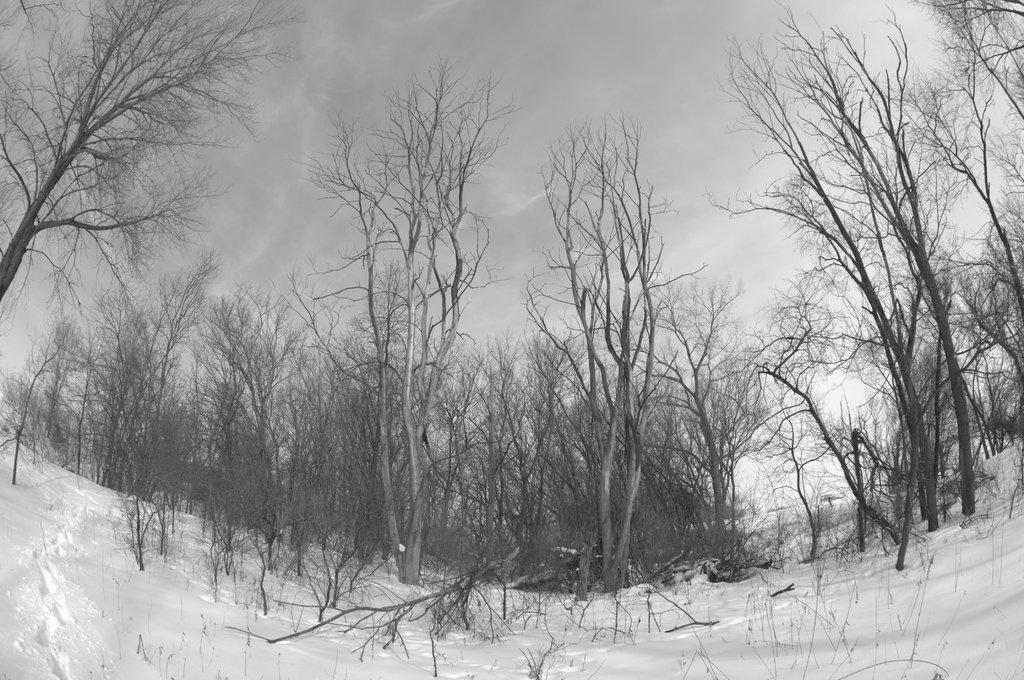What is on the snow in the image? There are cut down trees on the snow. What can be seen in the background of the image? There are bare trees in the background. What is visible in the sky in the image? Clouds are visible in the sky. What type of wall can be seen in the image? There is no wall present in the image; it features cut down trees on the snow and bare trees in the background. What is the visibility like in the image due to the fog? There is no fog present in the image; it features clouds visible in the sky. 